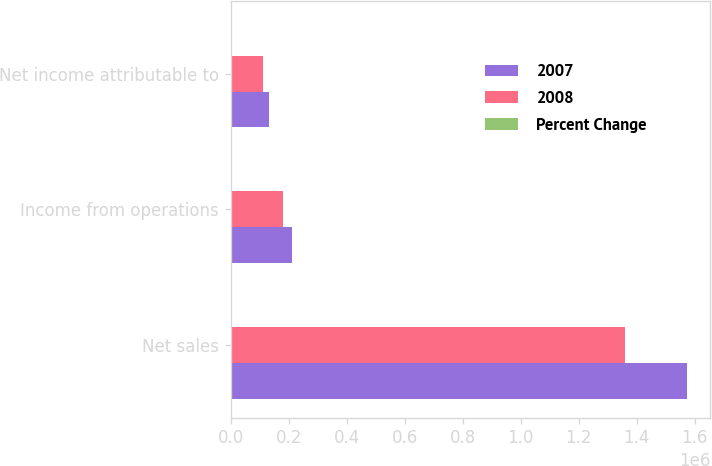Convert chart to OTSL. <chart><loc_0><loc_0><loc_500><loc_500><stacked_bar_chart><ecel><fcel>Net sales<fcel>Income from operations<fcel>Net income attributable to<nl><fcel>2007<fcel>1.57475e+06<fcel>212516<fcel>130551<nl><fcel>2008<fcel>1.36009e+06<fcel>179741<fcel>109570<nl><fcel>Percent Change<fcel>15.8<fcel>18.2<fcel>19.2<nl></chart> 